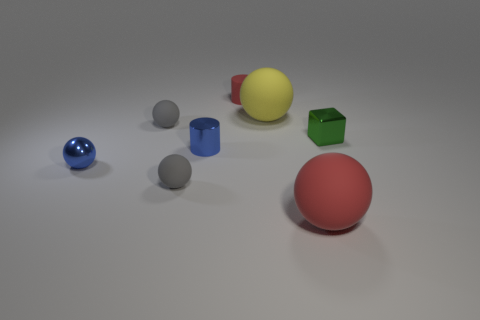Is the number of tiny matte cylinders right of the matte cylinder the same as the number of large gray matte spheres?
Offer a terse response. Yes. What is the size of the red matte thing that is in front of the tiny block?
Give a very brief answer. Large. What number of big yellow things have the same shape as the large red rubber object?
Provide a short and direct response. 1. There is a small thing that is right of the small blue cylinder and left of the green metal block; what is its material?
Offer a very short reply. Rubber. Is the small blue cylinder made of the same material as the big yellow sphere?
Provide a short and direct response. No. How many gray rubber objects are there?
Your response must be concise. 2. What color is the large rubber ball that is in front of the gray ball that is in front of the green metal object that is on the right side of the tiny red rubber cylinder?
Your answer should be compact. Red. Does the metallic cube have the same color as the tiny matte cylinder?
Your response must be concise. No. How many things are left of the green metal object and in front of the yellow ball?
Your answer should be very brief. 5. What number of shiny objects are green things or tiny spheres?
Provide a short and direct response. 2. 